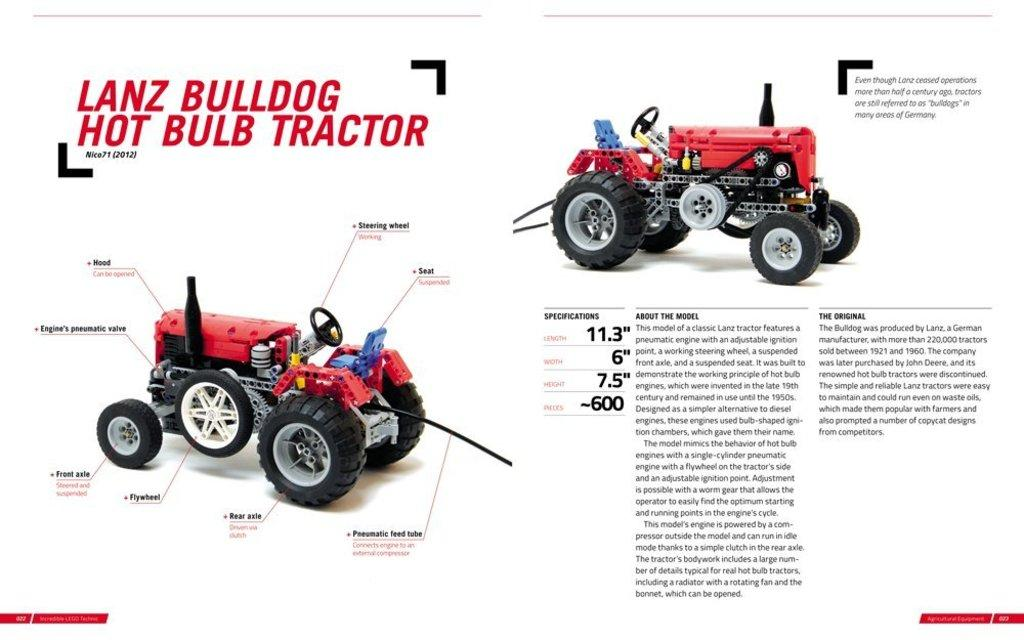What can be seen in the image? There are vehicles in the image. Where is text located in the image? There is text on the left side and the right side of the image. What type of pickle is being served to the minister in the image? There is no minister or pickle present in the image. Is there a bike visible in the image? There is no bike visible in the image. 